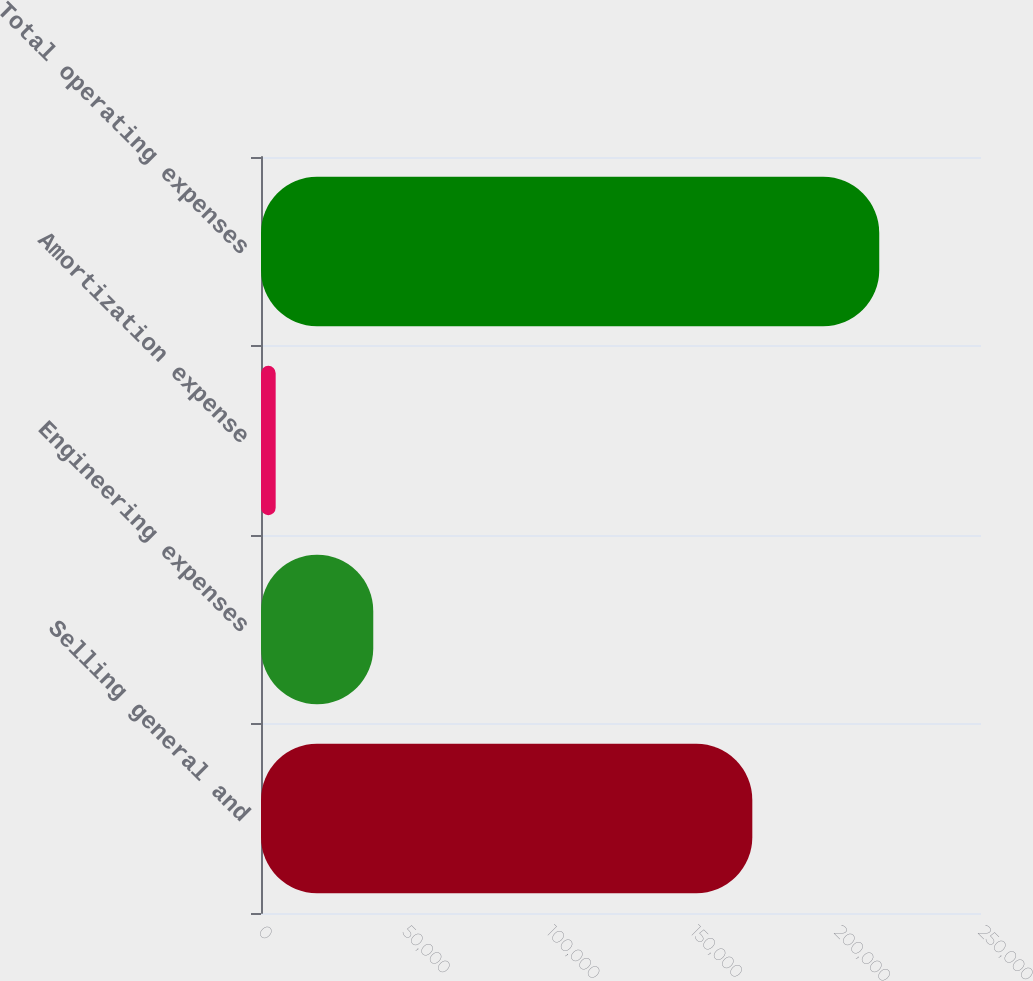<chart> <loc_0><loc_0><loc_500><loc_500><bar_chart><fcel>Selling general and<fcel>Engineering expenses<fcel>Amortization expense<fcel>Total operating expenses<nl><fcel>170597<fcel>38981<fcel>5092<fcel>214670<nl></chart> 